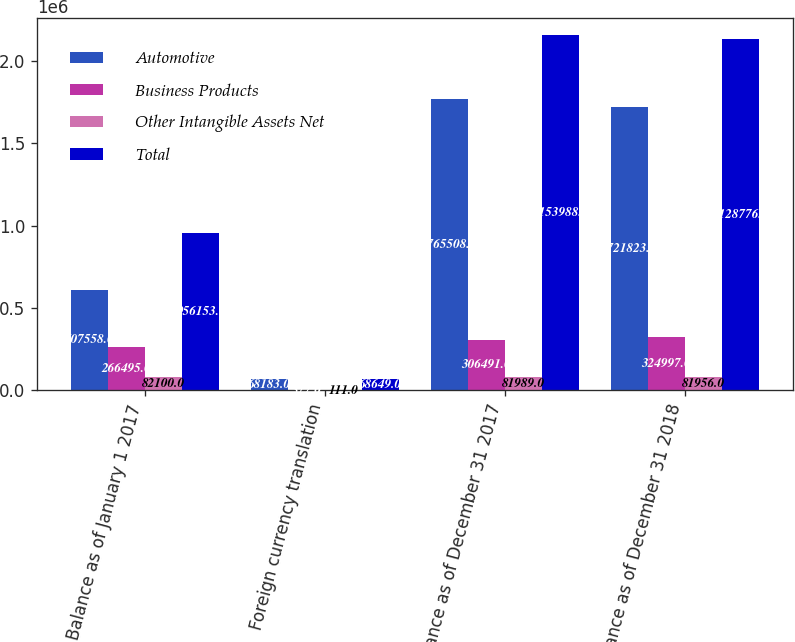Convert chart to OTSL. <chart><loc_0><loc_0><loc_500><loc_500><stacked_bar_chart><ecel><fcel>Balance as of January 1 2017<fcel>Foreign currency translation<fcel>Balance as of December 31 2017<fcel>Balance as of December 31 2018<nl><fcel>Automotive<fcel>607558<fcel>68183<fcel>1.76551e+06<fcel>1.72182e+06<nl><fcel>Business Products<fcel>266495<fcel>577<fcel>306491<fcel>324997<nl><fcel>Other Intangible Assets Net<fcel>82100<fcel>111<fcel>81989<fcel>81956<nl><fcel>Total<fcel>956153<fcel>68649<fcel>2.15399e+06<fcel>2.12878e+06<nl></chart> 